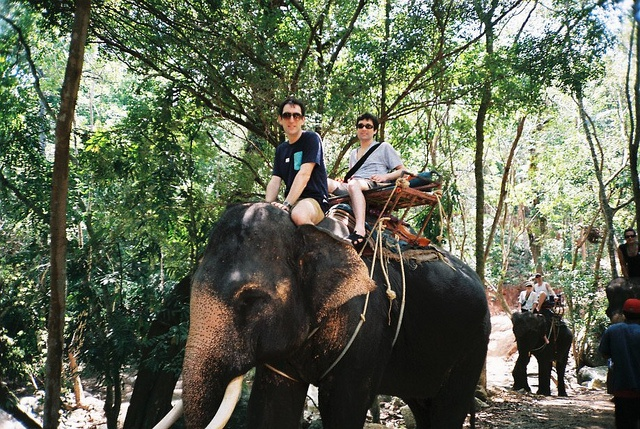Describe the objects in this image and their specific colors. I can see elephant in lightblue, black, gray, and maroon tones, people in lightblue, black, tan, and lightgray tones, people in lightblue, lightgray, black, darkgray, and tan tones, people in lightblue, black, navy, maroon, and blue tones, and elephant in lightblue, black, gray, white, and darkgray tones in this image. 